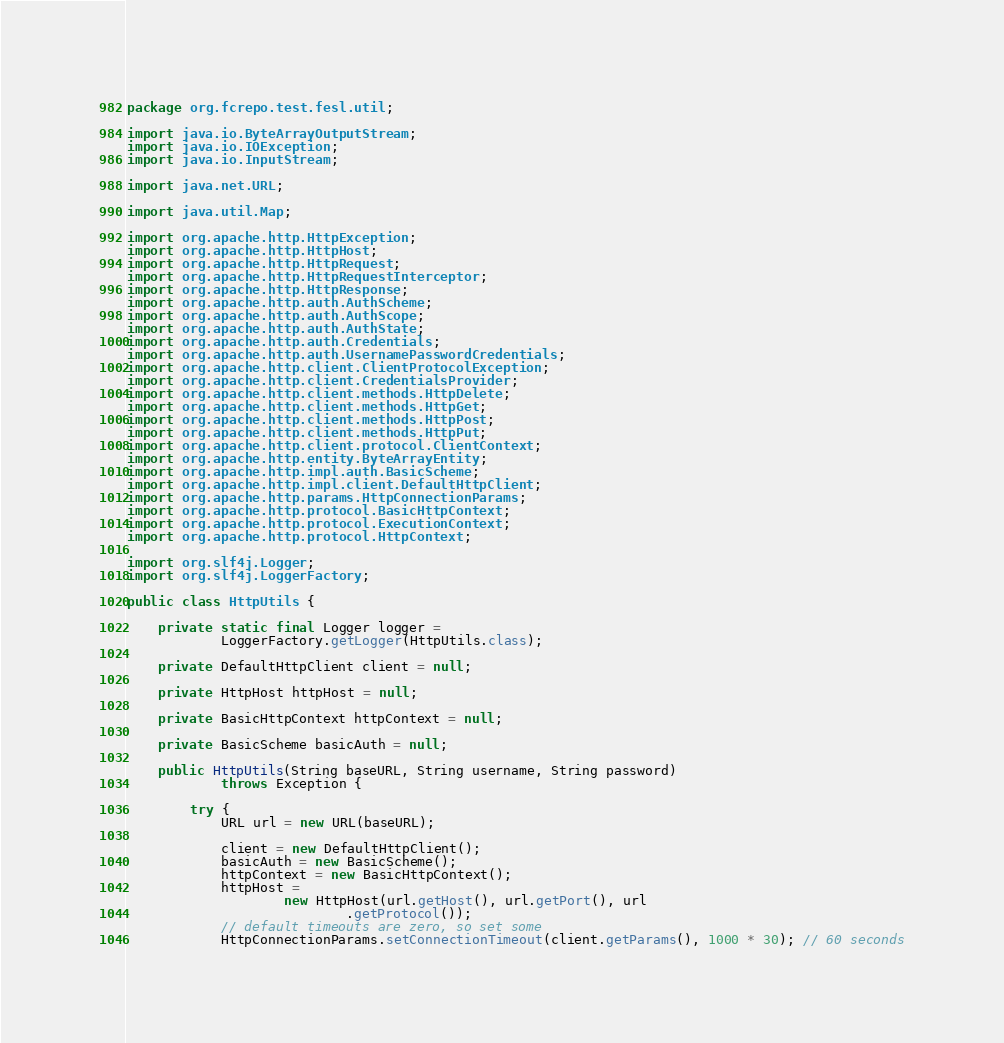<code> <loc_0><loc_0><loc_500><loc_500><_Java_>
package org.fcrepo.test.fesl.util;

import java.io.ByteArrayOutputStream;
import java.io.IOException;
import java.io.InputStream;

import java.net.URL;

import java.util.Map;

import org.apache.http.HttpException;
import org.apache.http.HttpHost;
import org.apache.http.HttpRequest;
import org.apache.http.HttpRequestInterceptor;
import org.apache.http.HttpResponse;
import org.apache.http.auth.AuthScheme;
import org.apache.http.auth.AuthScope;
import org.apache.http.auth.AuthState;
import org.apache.http.auth.Credentials;
import org.apache.http.auth.UsernamePasswordCredentials;
import org.apache.http.client.ClientProtocolException;
import org.apache.http.client.CredentialsProvider;
import org.apache.http.client.methods.HttpDelete;
import org.apache.http.client.methods.HttpGet;
import org.apache.http.client.methods.HttpPost;
import org.apache.http.client.methods.HttpPut;
import org.apache.http.client.protocol.ClientContext;
import org.apache.http.entity.ByteArrayEntity;
import org.apache.http.impl.auth.BasicScheme;
import org.apache.http.impl.client.DefaultHttpClient;
import org.apache.http.params.HttpConnectionParams;
import org.apache.http.protocol.BasicHttpContext;
import org.apache.http.protocol.ExecutionContext;
import org.apache.http.protocol.HttpContext;

import org.slf4j.Logger;
import org.slf4j.LoggerFactory;

public class HttpUtils {

    private static final Logger logger =
            LoggerFactory.getLogger(HttpUtils.class);

    private DefaultHttpClient client = null;

    private HttpHost httpHost = null;

    private BasicHttpContext httpContext = null;

    private BasicScheme basicAuth = null;

    public HttpUtils(String baseURL, String username, String password)
            throws Exception {

        try {
            URL url = new URL(baseURL);

            client = new DefaultHttpClient();
            basicAuth = new BasicScheme();
            httpContext = new BasicHttpContext();
            httpHost =
                    new HttpHost(url.getHost(), url.getPort(), url
                            .getProtocol());
            // default timeouts are zero, so set some
            HttpConnectionParams.setConnectionTimeout(client.getParams(), 1000 * 30); // 60 seconds</code> 